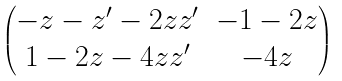<formula> <loc_0><loc_0><loc_500><loc_500>\begin{pmatrix} - z - z ^ { \prime } - 2 z z ^ { \prime } & - 1 - 2 z \\ 1 - 2 z - 4 z z ^ { \prime } & - 4 z \end{pmatrix}</formula> 